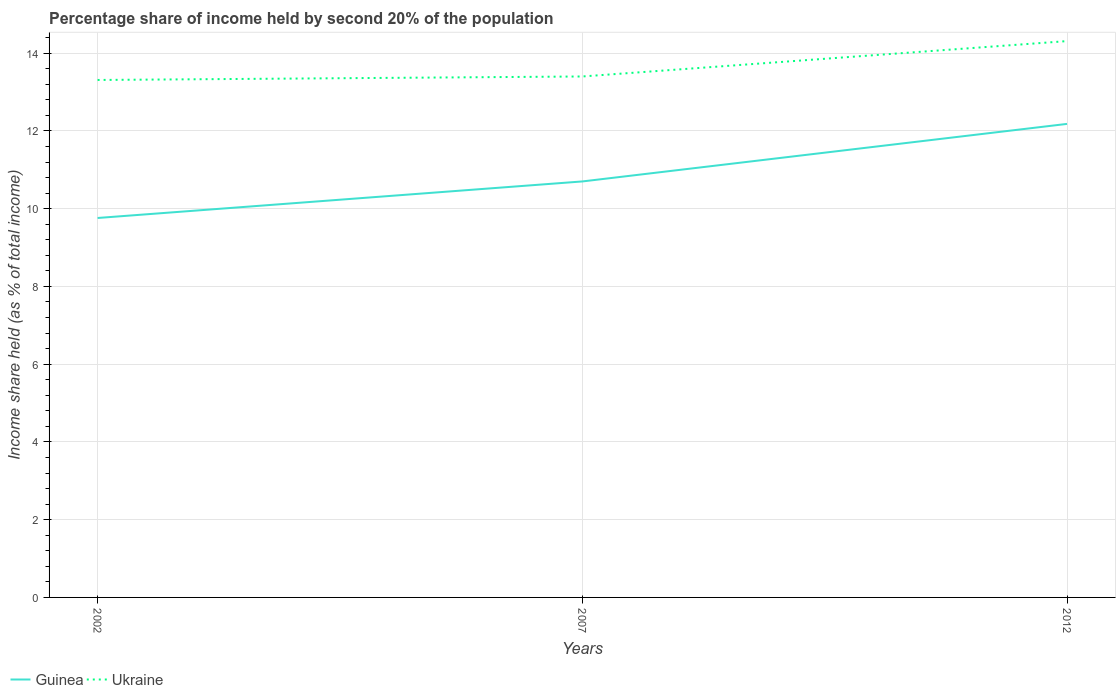How many different coloured lines are there?
Provide a succinct answer. 2. Does the line corresponding to Guinea intersect with the line corresponding to Ukraine?
Provide a succinct answer. No. Is the number of lines equal to the number of legend labels?
Offer a very short reply. Yes. Across all years, what is the maximum share of income held by second 20% of the population in Ukraine?
Offer a very short reply. 13.31. What is the total share of income held by second 20% of the population in Guinea in the graph?
Give a very brief answer. -2.42. How many years are there in the graph?
Provide a short and direct response. 3. What is the difference between two consecutive major ticks on the Y-axis?
Ensure brevity in your answer.  2. Are the values on the major ticks of Y-axis written in scientific E-notation?
Offer a very short reply. No. Where does the legend appear in the graph?
Your response must be concise. Bottom left. How many legend labels are there?
Keep it short and to the point. 2. What is the title of the graph?
Your answer should be compact. Percentage share of income held by second 20% of the population. Does "Uruguay" appear as one of the legend labels in the graph?
Your response must be concise. No. What is the label or title of the X-axis?
Offer a very short reply. Years. What is the label or title of the Y-axis?
Your answer should be compact. Income share held (as % of total income). What is the Income share held (as % of total income) of Guinea in 2002?
Your answer should be compact. 9.76. What is the Income share held (as % of total income) in Ukraine in 2002?
Provide a succinct answer. 13.31. What is the Income share held (as % of total income) of Guinea in 2012?
Offer a very short reply. 12.18. What is the Income share held (as % of total income) of Ukraine in 2012?
Your answer should be compact. 14.31. Across all years, what is the maximum Income share held (as % of total income) in Guinea?
Offer a very short reply. 12.18. Across all years, what is the maximum Income share held (as % of total income) of Ukraine?
Offer a terse response. 14.31. Across all years, what is the minimum Income share held (as % of total income) in Guinea?
Your answer should be very brief. 9.76. Across all years, what is the minimum Income share held (as % of total income) in Ukraine?
Offer a terse response. 13.31. What is the total Income share held (as % of total income) in Guinea in the graph?
Provide a short and direct response. 32.64. What is the total Income share held (as % of total income) in Ukraine in the graph?
Keep it short and to the point. 41.02. What is the difference between the Income share held (as % of total income) in Guinea in 2002 and that in 2007?
Provide a short and direct response. -0.94. What is the difference between the Income share held (as % of total income) in Ukraine in 2002 and that in 2007?
Offer a terse response. -0.09. What is the difference between the Income share held (as % of total income) of Guinea in 2002 and that in 2012?
Your answer should be very brief. -2.42. What is the difference between the Income share held (as % of total income) in Ukraine in 2002 and that in 2012?
Ensure brevity in your answer.  -1. What is the difference between the Income share held (as % of total income) of Guinea in 2007 and that in 2012?
Keep it short and to the point. -1.48. What is the difference between the Income share held (as % of total income) of Ukraine in 2007 and that in 2012?
Provide a succinct answer. -0.91. What is the difference between the Income share held (as % of total income) in Guinea in 2002 and the Income share held (as % of total income) in Ukraine in 2007?
Provide a short and direct response. -3.64. What is the difference between the Income share held (as % of total income) in Guinea in 2002 and the Income share held (as % of total income) in Ukraine in 2012?
Your answer should be very brief. -4.55. What is the difference between the Income share held (as % of total income) of Guinea in 2007 and the Income share held (as % of total income) of Ukraine in 2012?
Give a very brief answer. -3.61. What is the average Income share held (as % of total income) in Guinea per year?
Offer a terse response. 10.88. What is the average Income share held (as % of total income) in Ukraine per year?
Offer a very short reply. 13.67. In the year 2002, what is the difference between the Income share held (as % of total income) of Guinea and Income share held (as % of total income) of Ukraine?
Provide a succinct answer. -3.55. In the year 2007, what is the difference between the Income share held (as % of total income) of Guinea and Income share held (as % of total income) of Ukraine?
Offer a terse response. -2.7. In the year 2012, what is the difference between the Income share held (as % of total income) of Guinea and Income share held (as % of total income) of Ukraine?
Your response must be concise. -2.13. What is the ratio of the Income share held (as % of total income) in Guinea in 2002 to that in 2007?
Your answer should be compact. 0.91. What is the ratio of the Income share held (as % of total income) in Ukraine in 2002 to that in 2007?
Offer a very short reply. 0.99. What is the ratio of the Income share held (as % of total income) of Guinea in 2002 to that in 2012?
Give a very brief answer. 0.8. What is the ratio of the Income share held (as % of total income) in Ukraine in 2002 to that in 2012?
Provide a short and direct response. 0.93. What is the ratio of the Income share held (as % of total income) in Guinea in 2007 to that in 2012?
Provide a short and direct response. 0.88. What is the ratio of the Income share held (as % of total income) of Ukraine in 2007 to that in 2012?
Your answer should be compact. 0.94. What is the difference between the highest and the second highest Income share held (as % of total income) in Guinea?
Offer a very short reply. 1.48. What is the difference between the highest and the second highest Income share held (as % of total income) of Ukraine?
Give a very brief answer. 0.91. What is the difference between the highest and the lowest Income share held (as % of total income) in Guinea?
Your response must be concise. 2.42. What is the difference between the highest and the lowest Income share held (as % of total income) of Ukraine?
Your response must be concise. 1. 